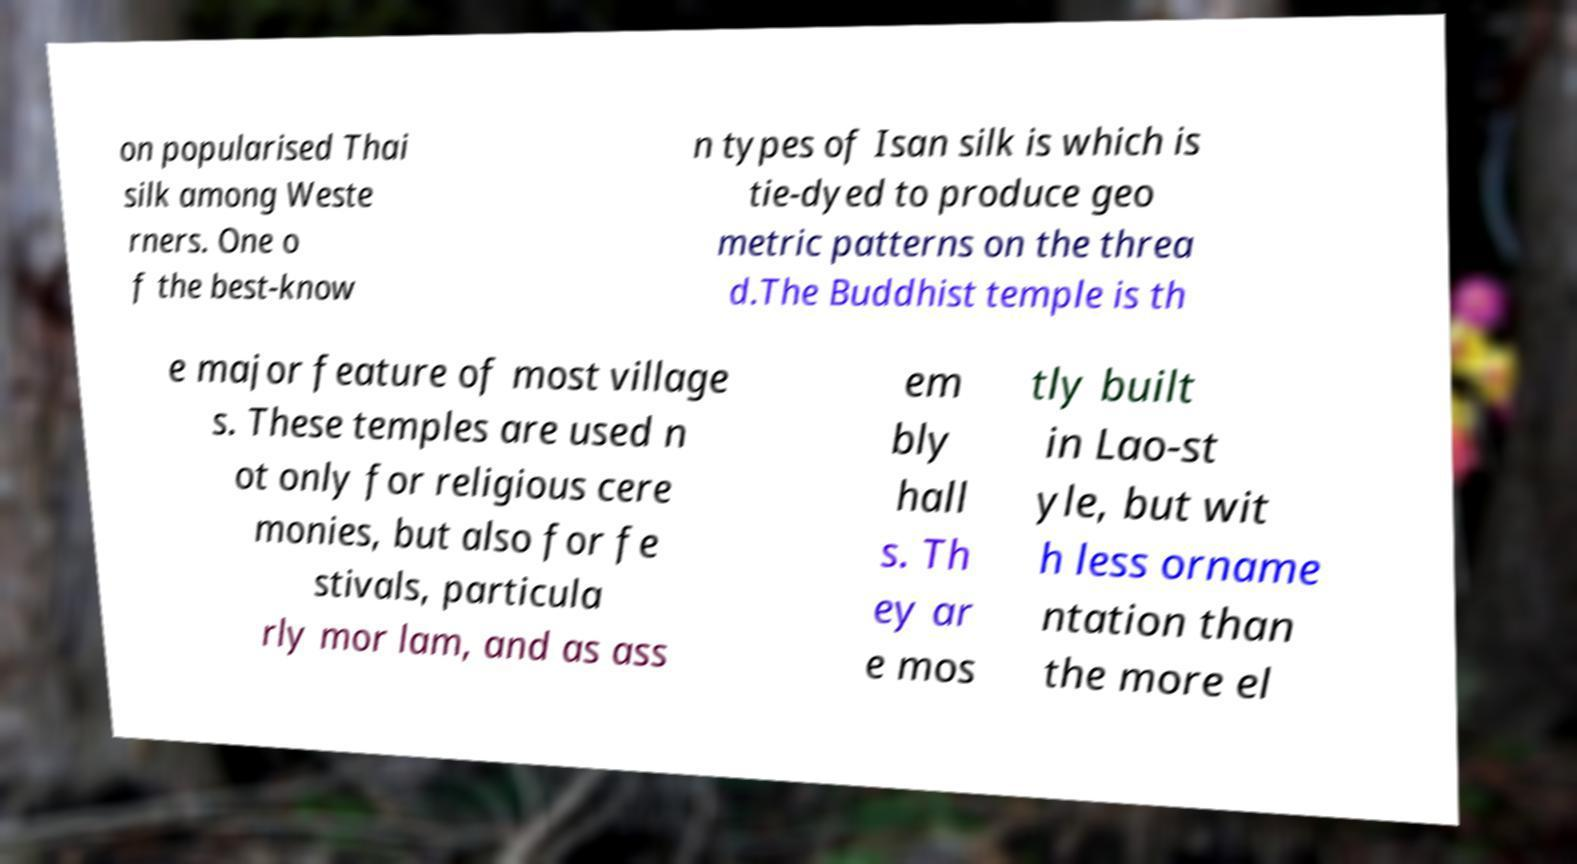For documentation purposes, I need the text within this image transcribed. Could you provide that? on popularised Thai silk among Weste rners. One o f the best-know n types of Isan silk is which is tie-dyed to produce geo metric patterns on the threa d.The Buddhist temple is th e major feature of most village s. These temples are used n ot only for religious cere monies, but also for fe stivals, particula rly mor lam, and as ass em bly hall s. Th ey ar e mos tly built in Lao-st yle, but wit h less orname ntation than the more el 